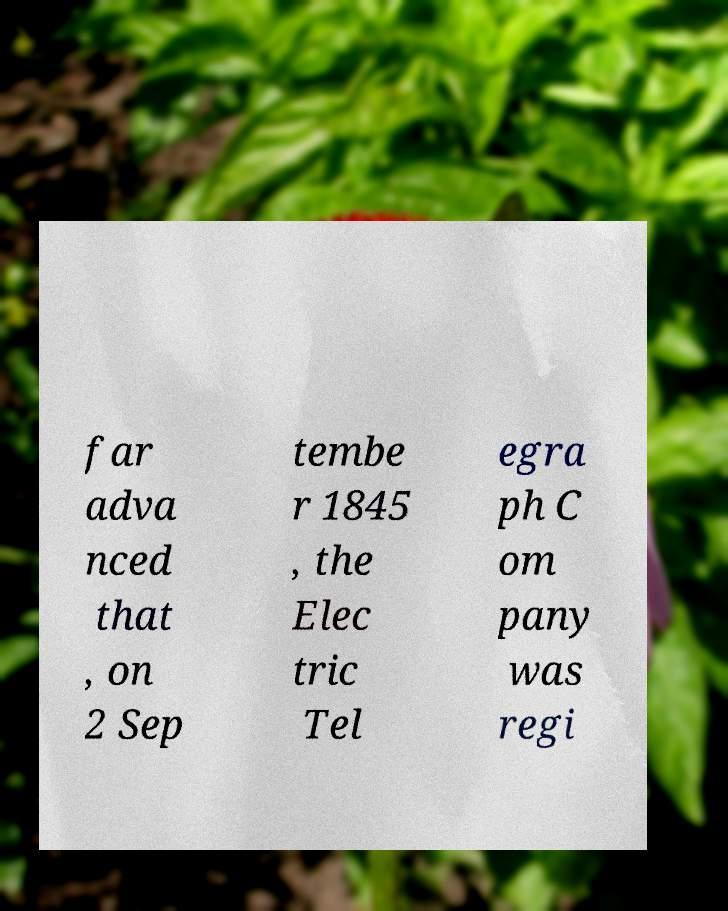For documentation purposes, I need the text within this image transcribed. Could you provide that? far adva nced that , on 2 Sep tembe r 1845 , the Elec tric Tel egra ph C om pany was regi 